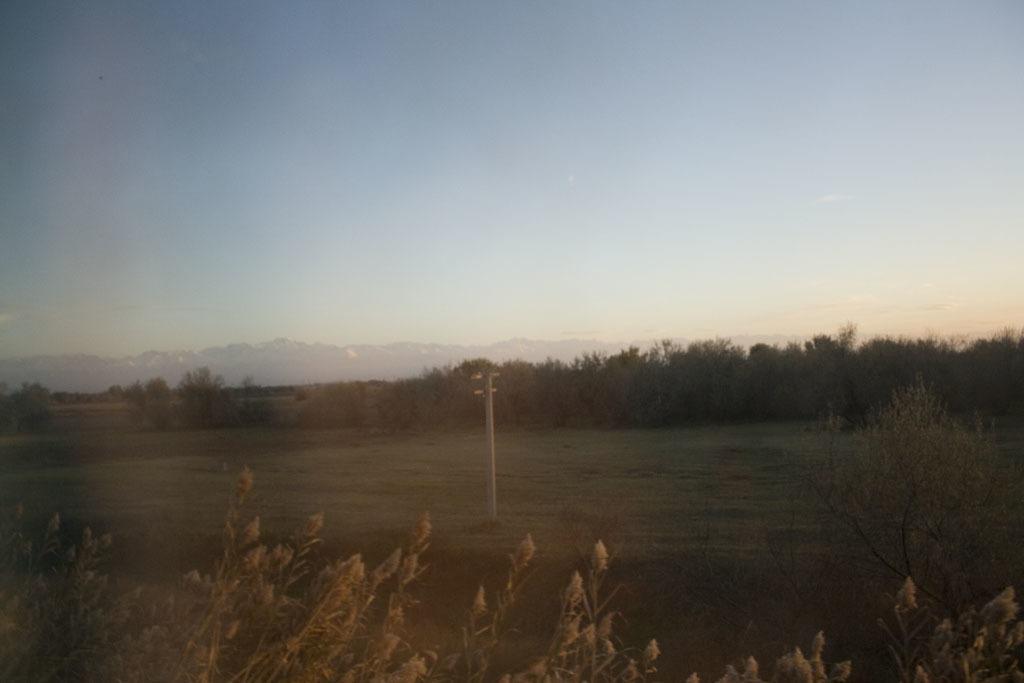Could you give a brief overview of what you see in this image? In the center of the image we can see a pole, trees, hills are there. At the top of the image sky is there. At the bottom of the image some plants, ground are there. 